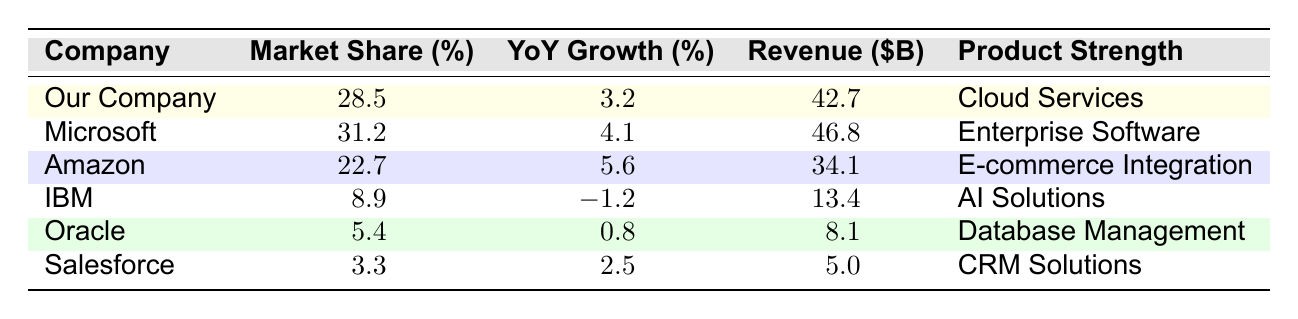What is the market share percentage of our company? According to the table, the market share of our company is listed as 28.5%.
Answer: 28.5% Which company has the highest revenue? From the table, Microsoft has the highest revenue at 46.8 billion dollars.
Answer: Microsoft Is the year-over-year growth for IBM positive? The table shows that IBM has a year-over-year growth of -1.2%, which indicates it is negative.
Answer: No What is the average market share of the top five competitors? To find the average, first add the market shares of Microsoft, Amazon, IBM, Oracle, and Salesforce: (31.2 + 22.7 + 8.9 + 5.4 + 3.3) = 71.5%. Then divide by the number of competitors (5), which gives us 71.5 / 5 = 14.3%.
Answer: 14.3% Which company has the strongest product according to their offerings? The table lists the product strengths, but 'strongest' is subjective. However, our company focuses on 'Cloud Services', which is currently a strong market area.
Answer: Our Company What is the revenue difference between Amazon and IBM? The revenue for Amazon is 34.1 billion dollars, and for IBM, it’s 13.4 billion dollars. The difference is 34.1 - 13.4 = 20.7 billion dollars.
Answer: 20.7 billion dollars Is there a company with a lower market share than our company? According to the table, Salesforce has a market share of 3.3%, which is lower than our company’s 28.5%.
Answer: Yes Which competitor has both the highest market share and the highest year-over-year growth? Microsoft has both the highest market share (31.2%) and year-over-year growth (4.1%) compared to other competitors.
Answer: Microsoft What is the total revenue generated by all six companies? First, sum the revenue of all companies: 42.7 + 46.8 + 34.1 + 13.4 + 8.1 + 5.0 = 150.1 billion dollars.
Answer: 150.1 billion dollars Which company shows a decrease in year-over-year growth? IBM is the only company in the table with a negative year-over-year growth of -1.2%.
Answer: IBM 